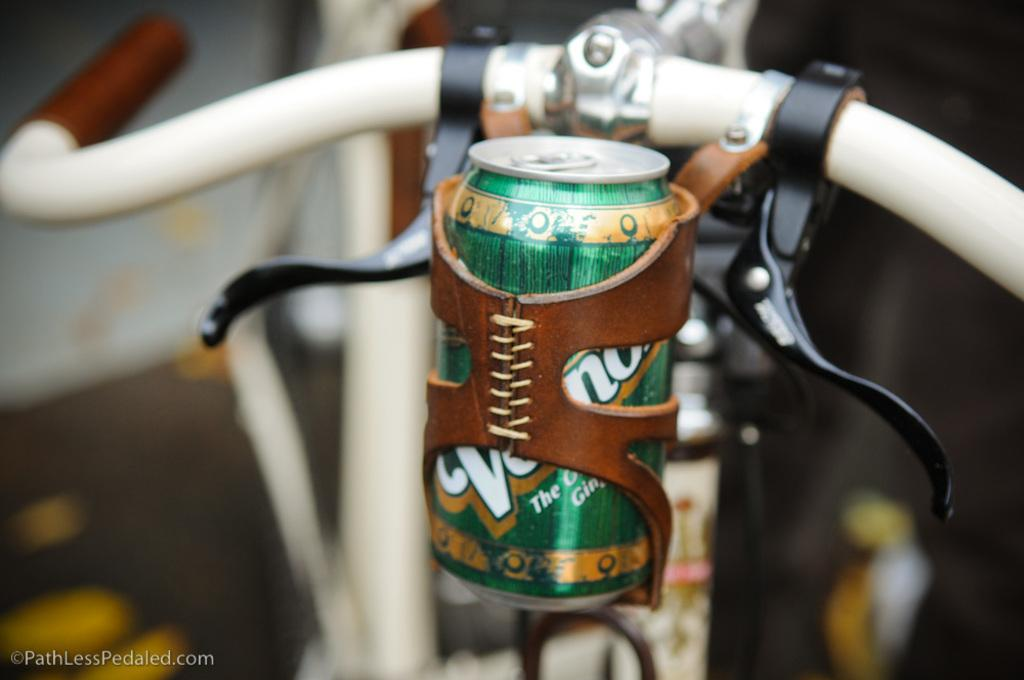What object is placed on the vehicle in the image? There is a bottle on a vehicle in the image. Can you describe the background of the image? The background of the image is blurry. What type of property is being represented by the apparel in the image? There is no apparel or property mentioned in the image, so it is not possible to answer that question. 